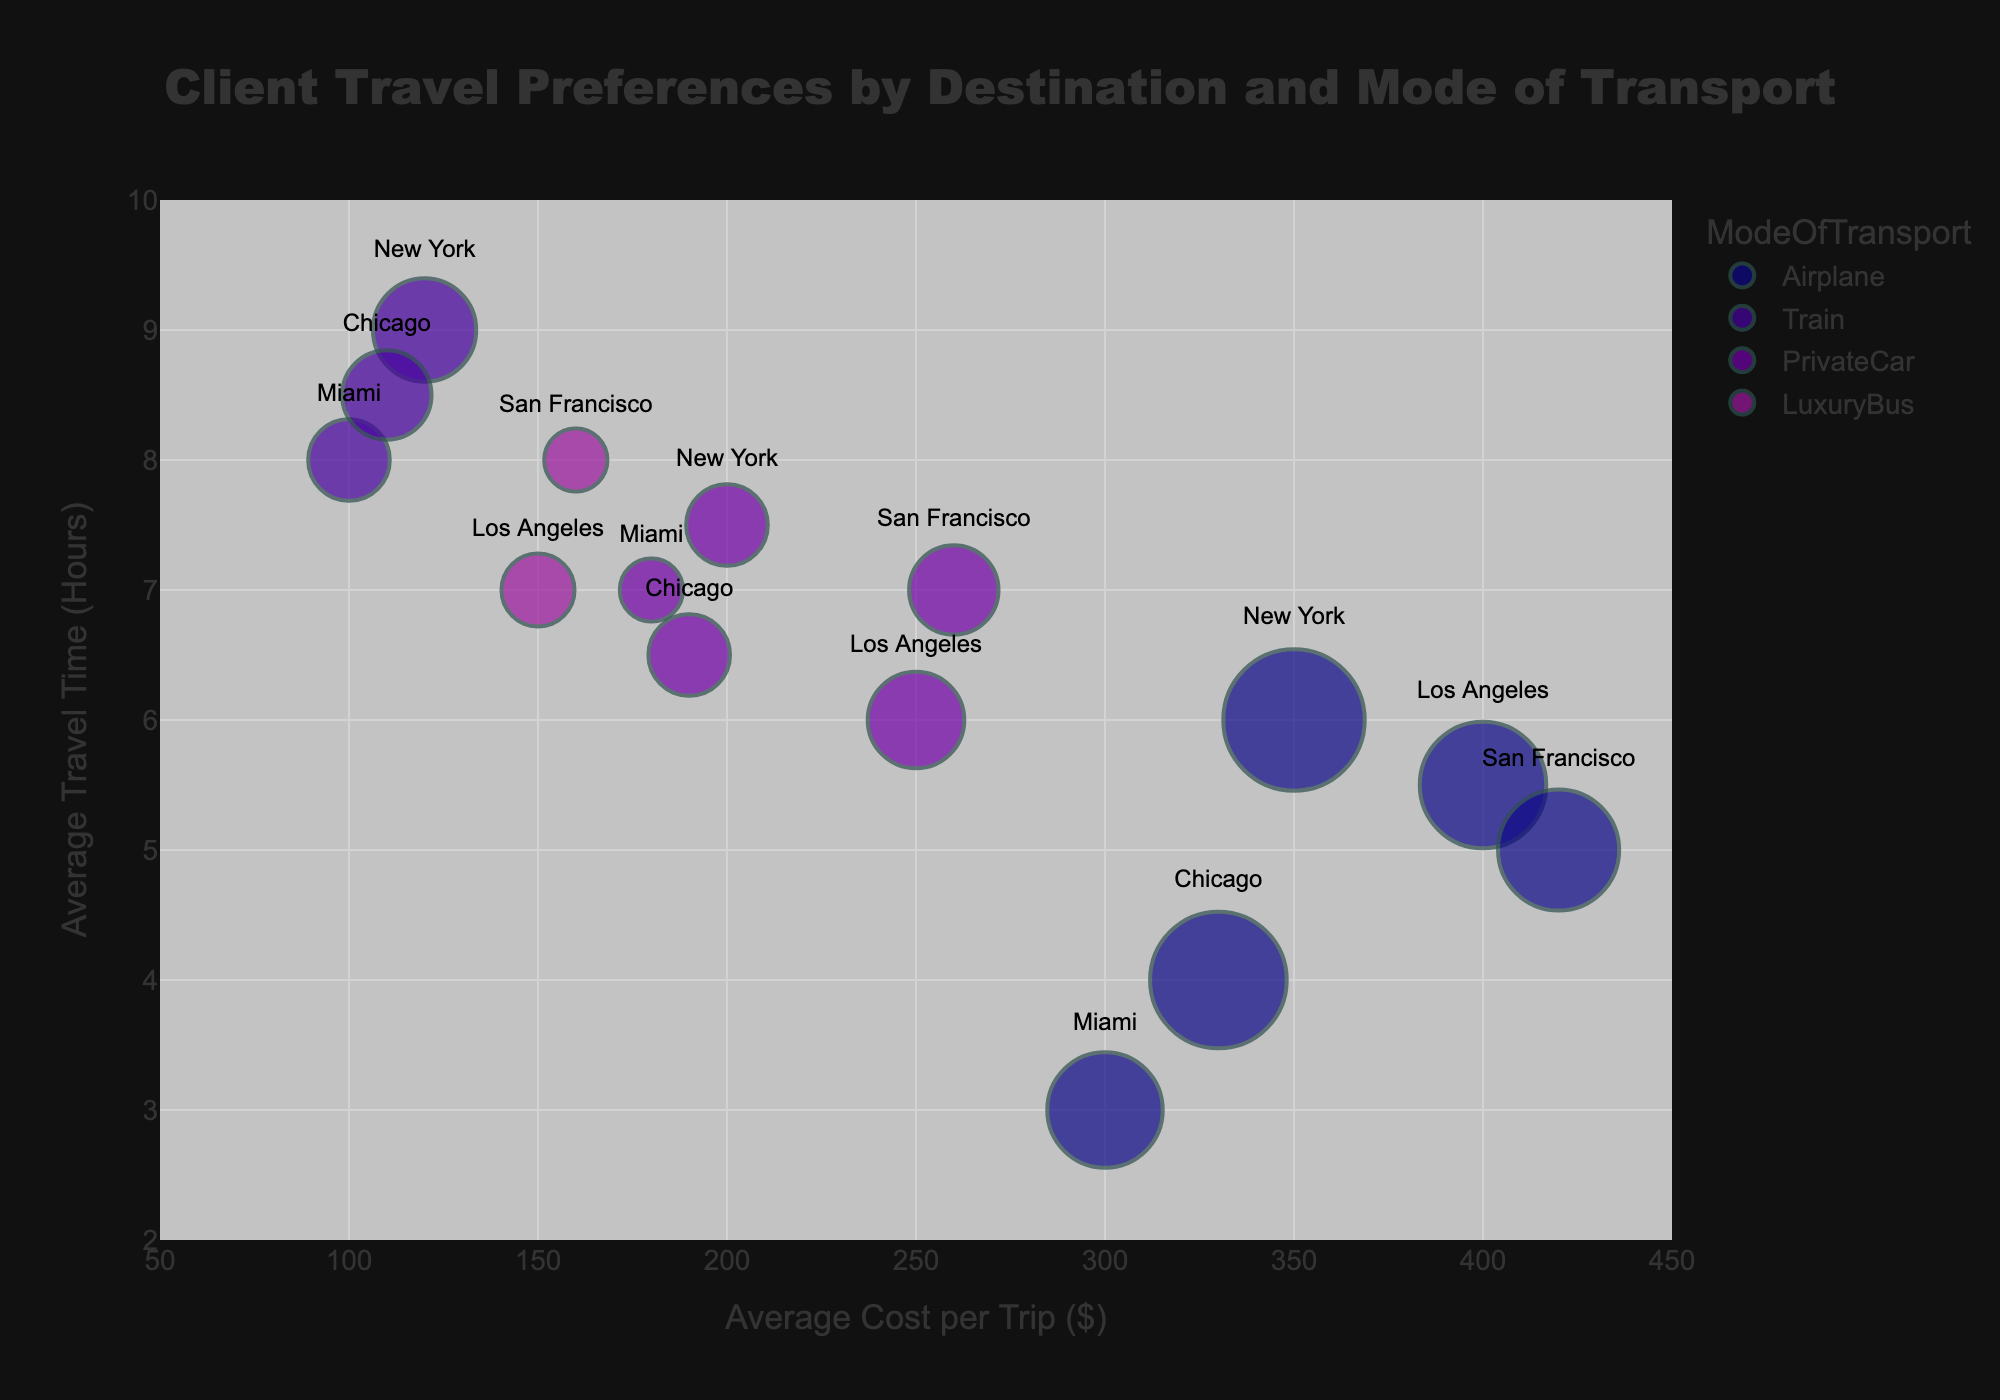What is the title of the figure? The title is located at the top center of the figure and usually provides a summary of what the graph depicts.
Answer: Client Travel Preferences by Destination and Mode of Transport How many different destinations are represented in the plot? The destinations are mentioned in the data points' hover names or text labels within the bubbles on the plot.
Answer: 5 Which mode of transport has the largest bubble for New York? Look for the bubble with the largest size labeled with "New York" on the plot, then check the color corresponding to the legend for modes of transport.
Answer: Airplane Between Train and PrivateCar for New York, which one has a higher average travel time? Compare the y-axis values for the bubbles corresponding to "Train" and "PrivateCar" at "New York".
Answer: Train What is the average cost per trip for the mode of transport with the lowest average travel time to Miami? Identify the bubble with the lowest y-axis value labeled "Miami", then read the corresponding x-axis value and check the color to identify the mode of transport.
Answer: $300 Which destination has the smallest bubble when using a LuxuryBus? Locate the bubbles labeled “LuxuryBus” and compare their sizes, then find the destination with the smallest bubble.
Answer: San Francisco Which mode of transport to Chicago has the lowest average cost per trip? Compare the x-axis values of the bubbles labeled “Chicago” and identify the mode of transport with the lowest value.
Answer: Train What is the difference in average travel time for Airplane between Los Angeles and San Francisco? Subtract the y-axis value of the “Airplane” bubble for Los Angeles from the y-axis value of the “Airplane” bubble for San Francisco.
Answer: 0.5 hours Between Airplane to Los Angeles and Airplane to Chicago, which has a higher average cost per trip? Compare the x-axis values of the “Airplane” bubbles for Los Angeles and Chicago.
Answer: Los Angeles What is the total number of clients traveling to Los Angeles? Sum up the client counts for all modes of transport to Los Angeles. 12 (Airplane) + 7 (PrivateCar) + 4 (LuxuryBus) = 23
Answer: 23 